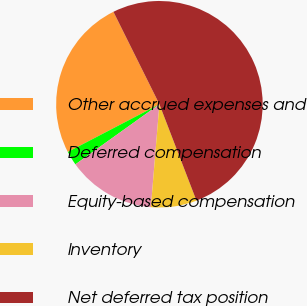Convert chart to OTSL. <chart><loc_0><loc_0><loc_500><loc_500><pie_chart><fcel>Other accrued expenses and<fcel>Deferred compensation<fcel>Equity-based compensation<fcel>Inventory<fcel>Net deferred tax position<nl><fcel>25.3%<fcel>2.24%<fcel>13.8%<fcel>7.16%<fcel>51.51%<nl></chart> 